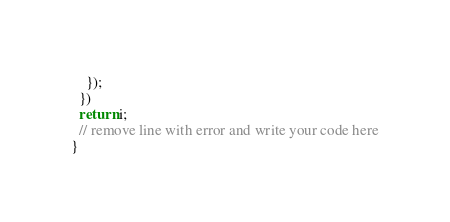<code> <loc_0><loc_0><loc_500><loc_500><_JavaScript_>    });
  })
  return i;
  // remove line with error and write your code here
}
</code> 